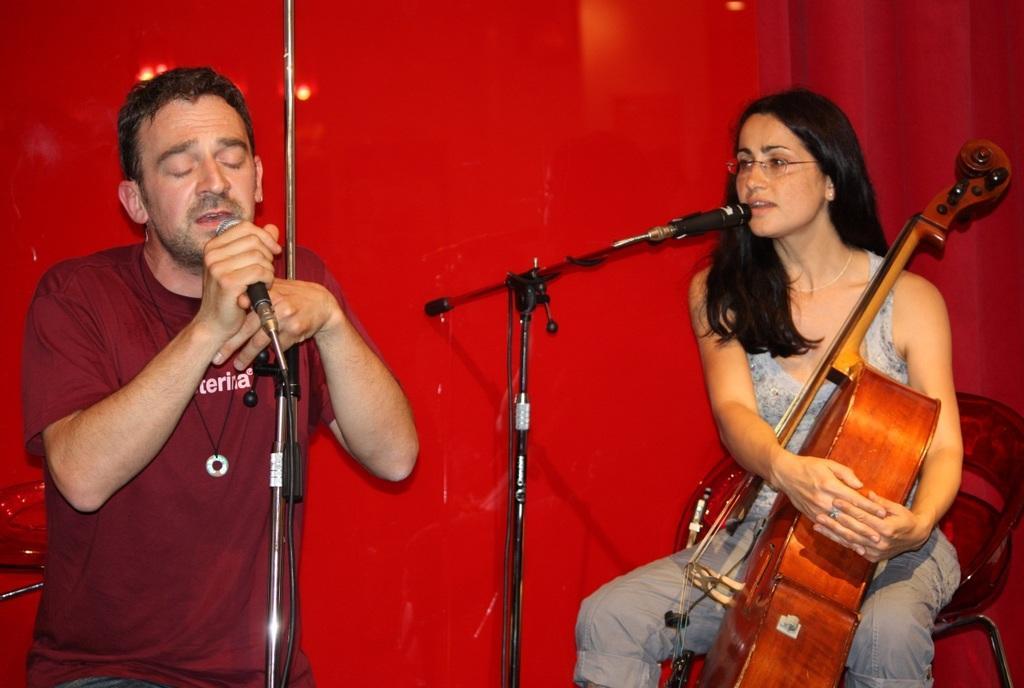In one or two sentences, can you explain what this image depicts? In this image, there is a person sitting in a chair in front of this mic and holding a musical instrument with her hands. There is an another person who is holding a mic with his hands. This person is wearing spectacles on her head. There is a red background behind these persons. 